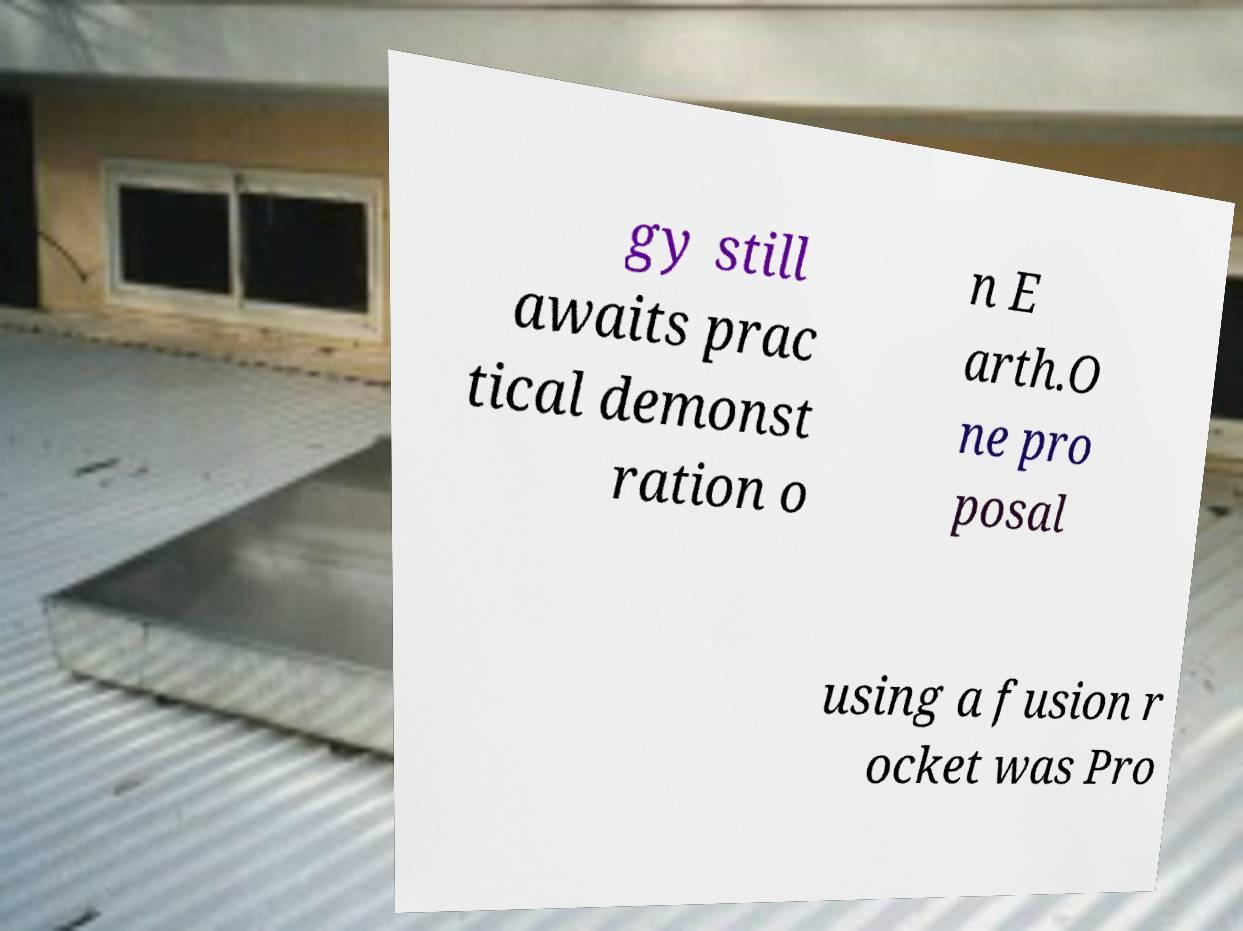Can you read and provide the text displayed in the image?This photo seems to have some interesting text. Can you extract and type it out for me? gy still awaits prac tical demonst ration o n E arth.O ne pro posal using a fusion r ocket was Pro 